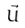<formula> <loc_0><loc_0><loc_500><loc_500>\vec { U }</formula> 